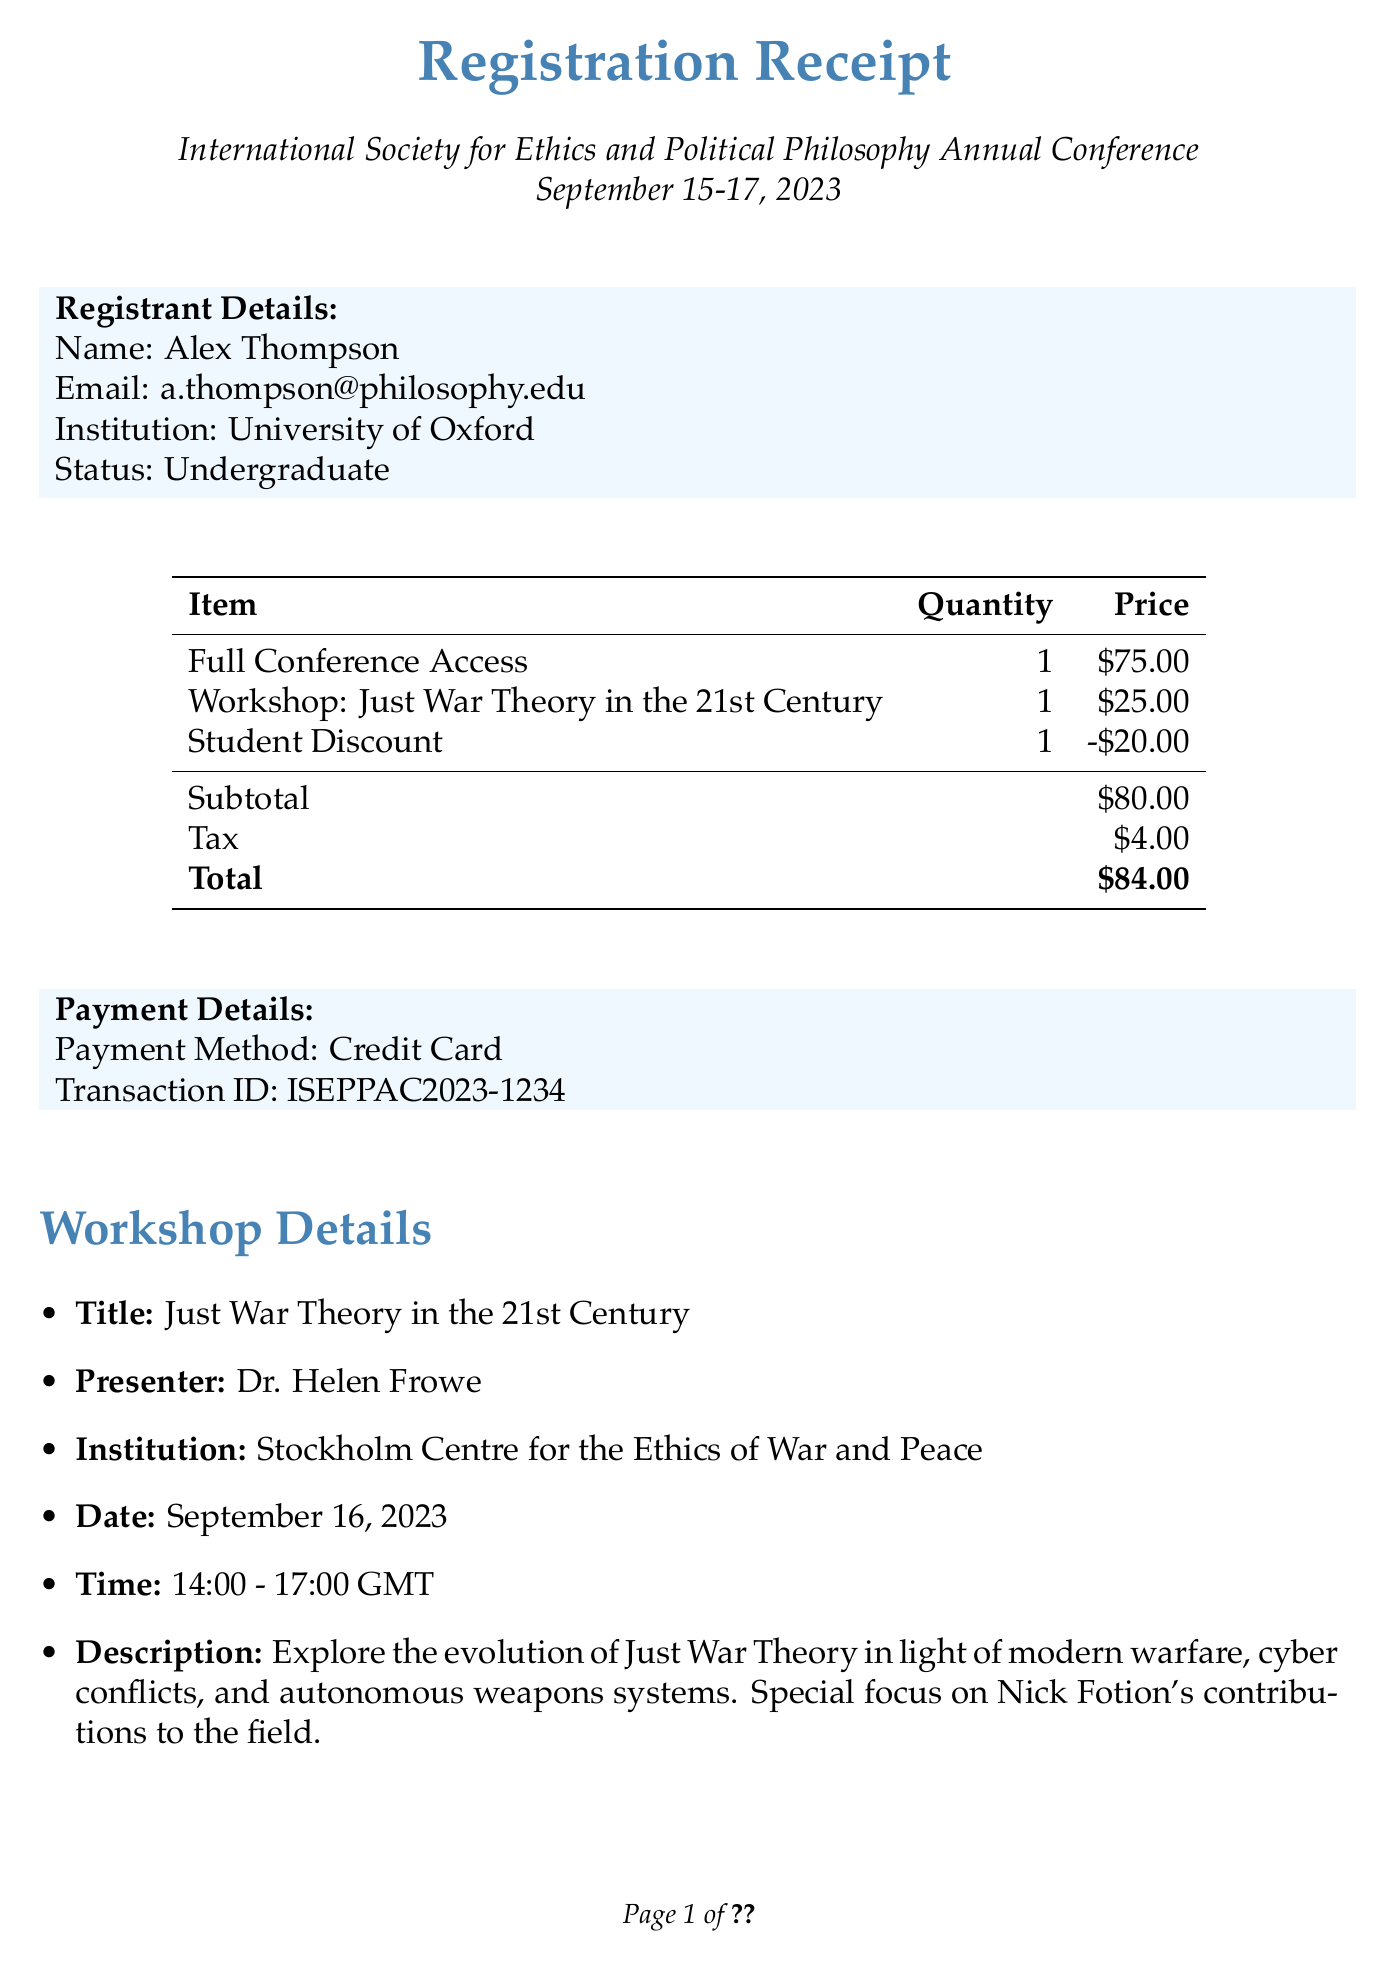What is the name of the conference? The name of the conference is specified in the document as the main title.
Answer: International Society for Ethics and Political Philosophy Annual Conference What is the registration total amount? The total amount is provided in the payment details section of the document, summing up subtotal and tax.
Answer: $84.00 Who is the presenter of the workshop? The document specifies the name of the presenter as part of the workshop details.
Answer: Dr. Helen Frowe What was the student discount applied? The amount of the student discount is explicitly stated in the registration items.
Answer: -$20.00 What is the date of the workshop? The workshop date is mentioned in the workshop details section of the document.
Answer: September 16, 2023 What email contact is provided for support? The document includes a specific email for support inquiries under additional information.
Answer: support@iseppac2023.org Which institution is associated with the presenter? The institution is included in the workshop details section related to the presenter.
Answer: Stockholm Centre for the Ethics of War and Peace What time is the workshop scheduled? The workshop time is outlined in the workshop details section.
Answer: 14:00 - 17:00 GMT 